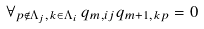<formula> <loc_0><loc_0><loc_500><loc_500>\forall _ { p \notin \Lambda _ { j } , k \in \Lambda _ { i } } \, q _ { m , i j } q _ { m + 1 , k p } = 0</formula> 